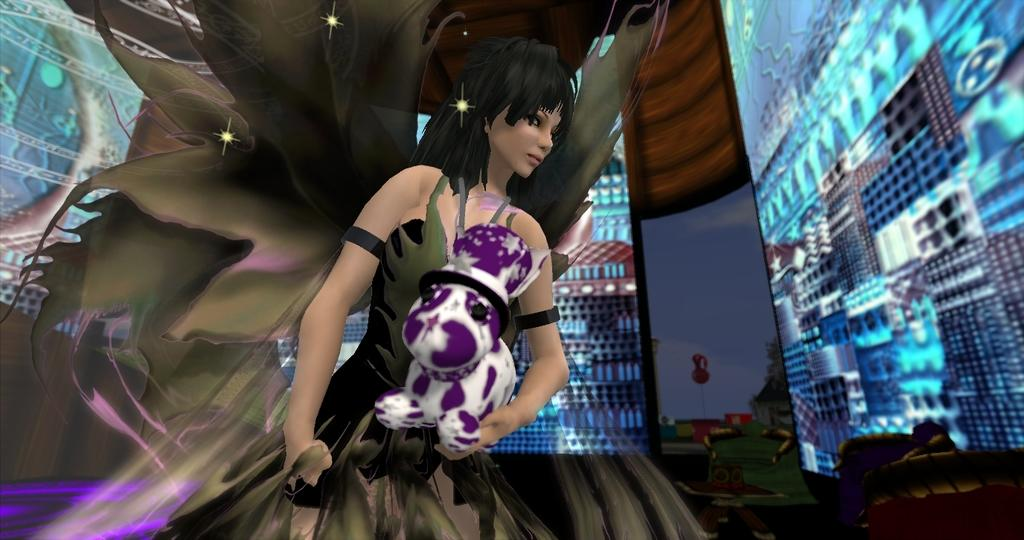What type of image is being described? The image is animated. What can be seen in the animated image? There is an animated picture of a woman holding a teddy bear. Are there any other elements or themes in the animated image? Yes, there are other themes present in the image. How many rifles can be seen in the animated image? There are no rifles present in the animated image. Is there a bat flying around the woman holding the teddy bear? There is no bat present in the animated image. 